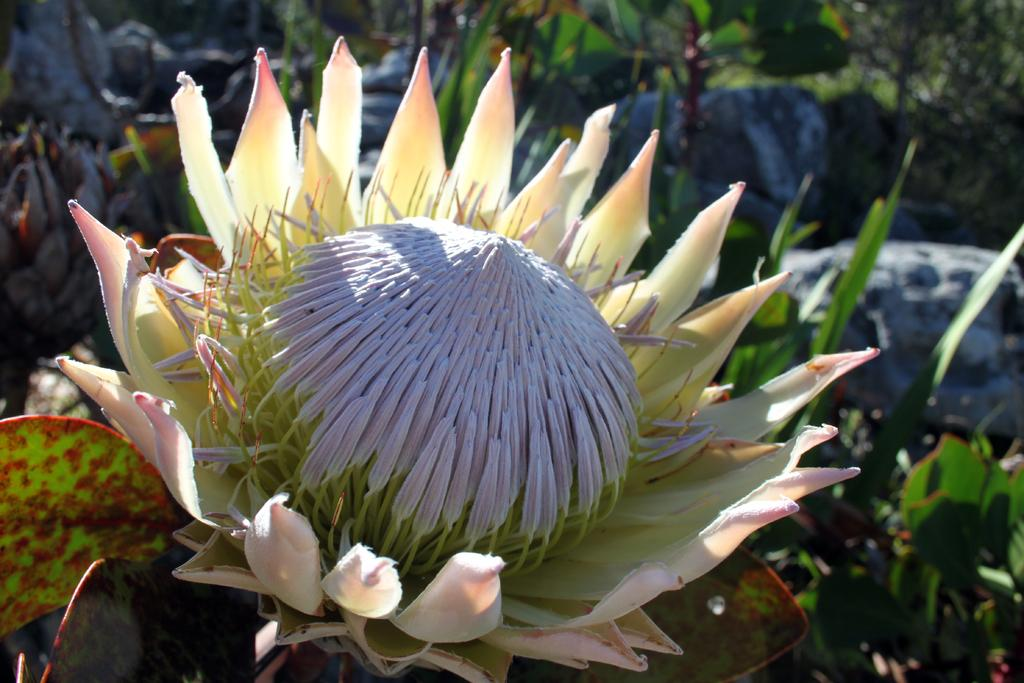What type of flower is in the image? There is a protea flower in the image. Is the protea flower alone in the image? No, the protea flower is accompanied by a plant. What can be seen in the background of the image? There are rocks and leaves visible in the background of the image. How many girls are smashing the protea flower on the stove in the image? There are no girls or stoves present in the image; it features a protea flower and a plant. 